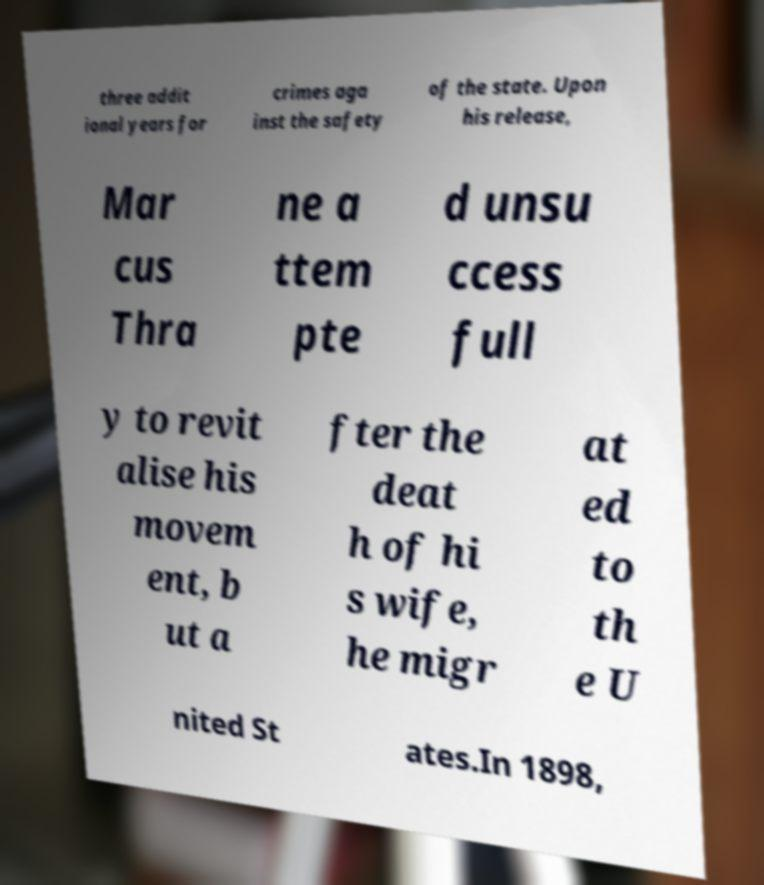What messages or text are displayed in this image? I need them in a readable, typed format. three addit ional years for crimes aga inst the safety of the state. Upon his release, Mar cus Thra ne a ttem pte d unsu ccess full y to revit alise his movem ent, b ut a fter the deat h of hi s wife, he migr at ed to th e U nited St ates.In 1898, 